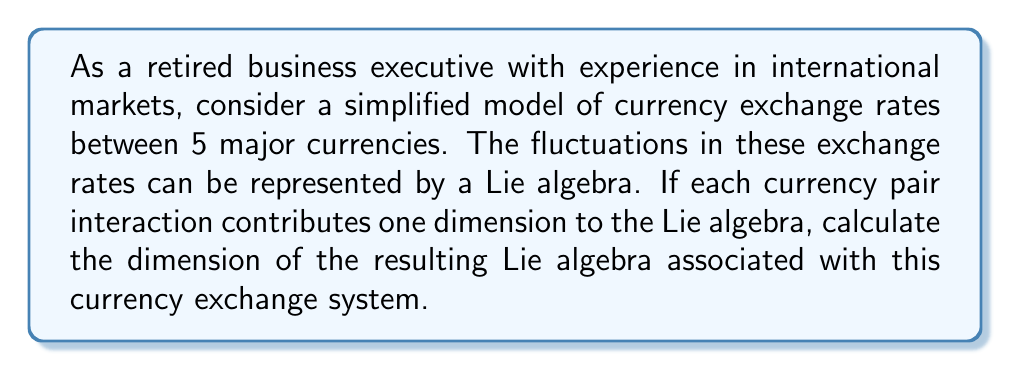Provide a solution to this math problem. To solve this problem, we need to understand how Lie algebras can be used to model currency exchange rate fluctuations and then calculate the dimension based on the given information.

1) In this model, each currency pair interaction contributes one dimension to the Lie algebra.

2) With 5 currencies, we need to calculate the number of unique currency pairs.

3) The number of unique currency pairs can be calculated using the combination formula:

   $$\binom{n}{2} = \frac{n!}{2!(n-2)!}$$

   where $n$ is the number of currencies.

4) Substituting $n = 5$ into the formula:

   $$\binom{5}{2} = \frac{5!}{2!(5-2)!} = \frac{5 \cdot 4}{2 \cdot 1} = 10$$

5) Therefore, there are 10 unique currency pairs in this system.

6) Since each currency pair interaction contributes one dimension to the Lie algebra, the dimension of the Lie algebra is equal to the number of unique currency pairs.

Thus, the dimension of the Lie algebra associated with this currency exchange system is 10.
Answer: The dimension of the Lie algebra is 10. 